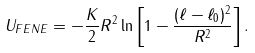Convert formula to latex. <formula><loc_0><loc_0><loc_500><loc_500>U _ { F E N E } = - \frac { K } { 2 } R ^ { 2 } \ln \left [ 1 - \frac { ( \ell - \ell _ { 0 } ) ^ { 2 } } { R ^ { 2 } } \right ] .</formula> 